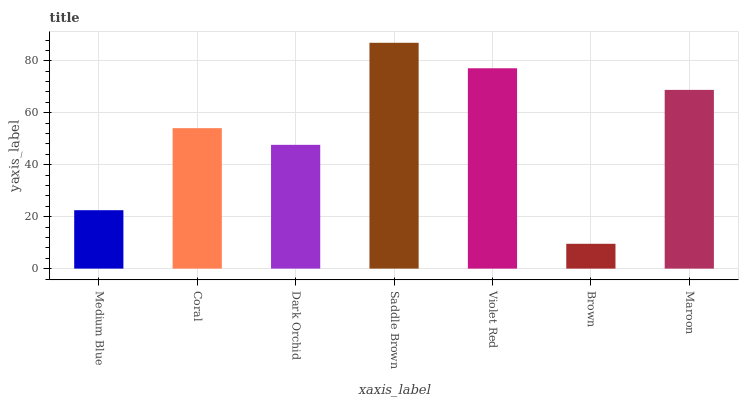Is Brown the minimum?
Answer yes or no. Yes. Is Saddle Brown the maximum?
Answer yes or no. Yes. Is Coral the minimum?
Answer yes or no. No. Is Coral the maximum?
Answer yes or no. No. Is Coral greater than Medium Blue?
Answer yes or no. Yes. Is Medium Blue less than Coral?
Answer yes or no. Yes. Is Medium Blue greater than Coral?
Answer yes or no. No. Is Coral less than Medium Blue?
Answer yes or no. No. Is Coral the high median?
Answer yes or no. Yes. Is Coral the low median?
Answer yes or no. Yes. Is Dark Orchid the high median?
Answer yes or no. No. Is Violet Red the low median?
Answer yes or no. No. 